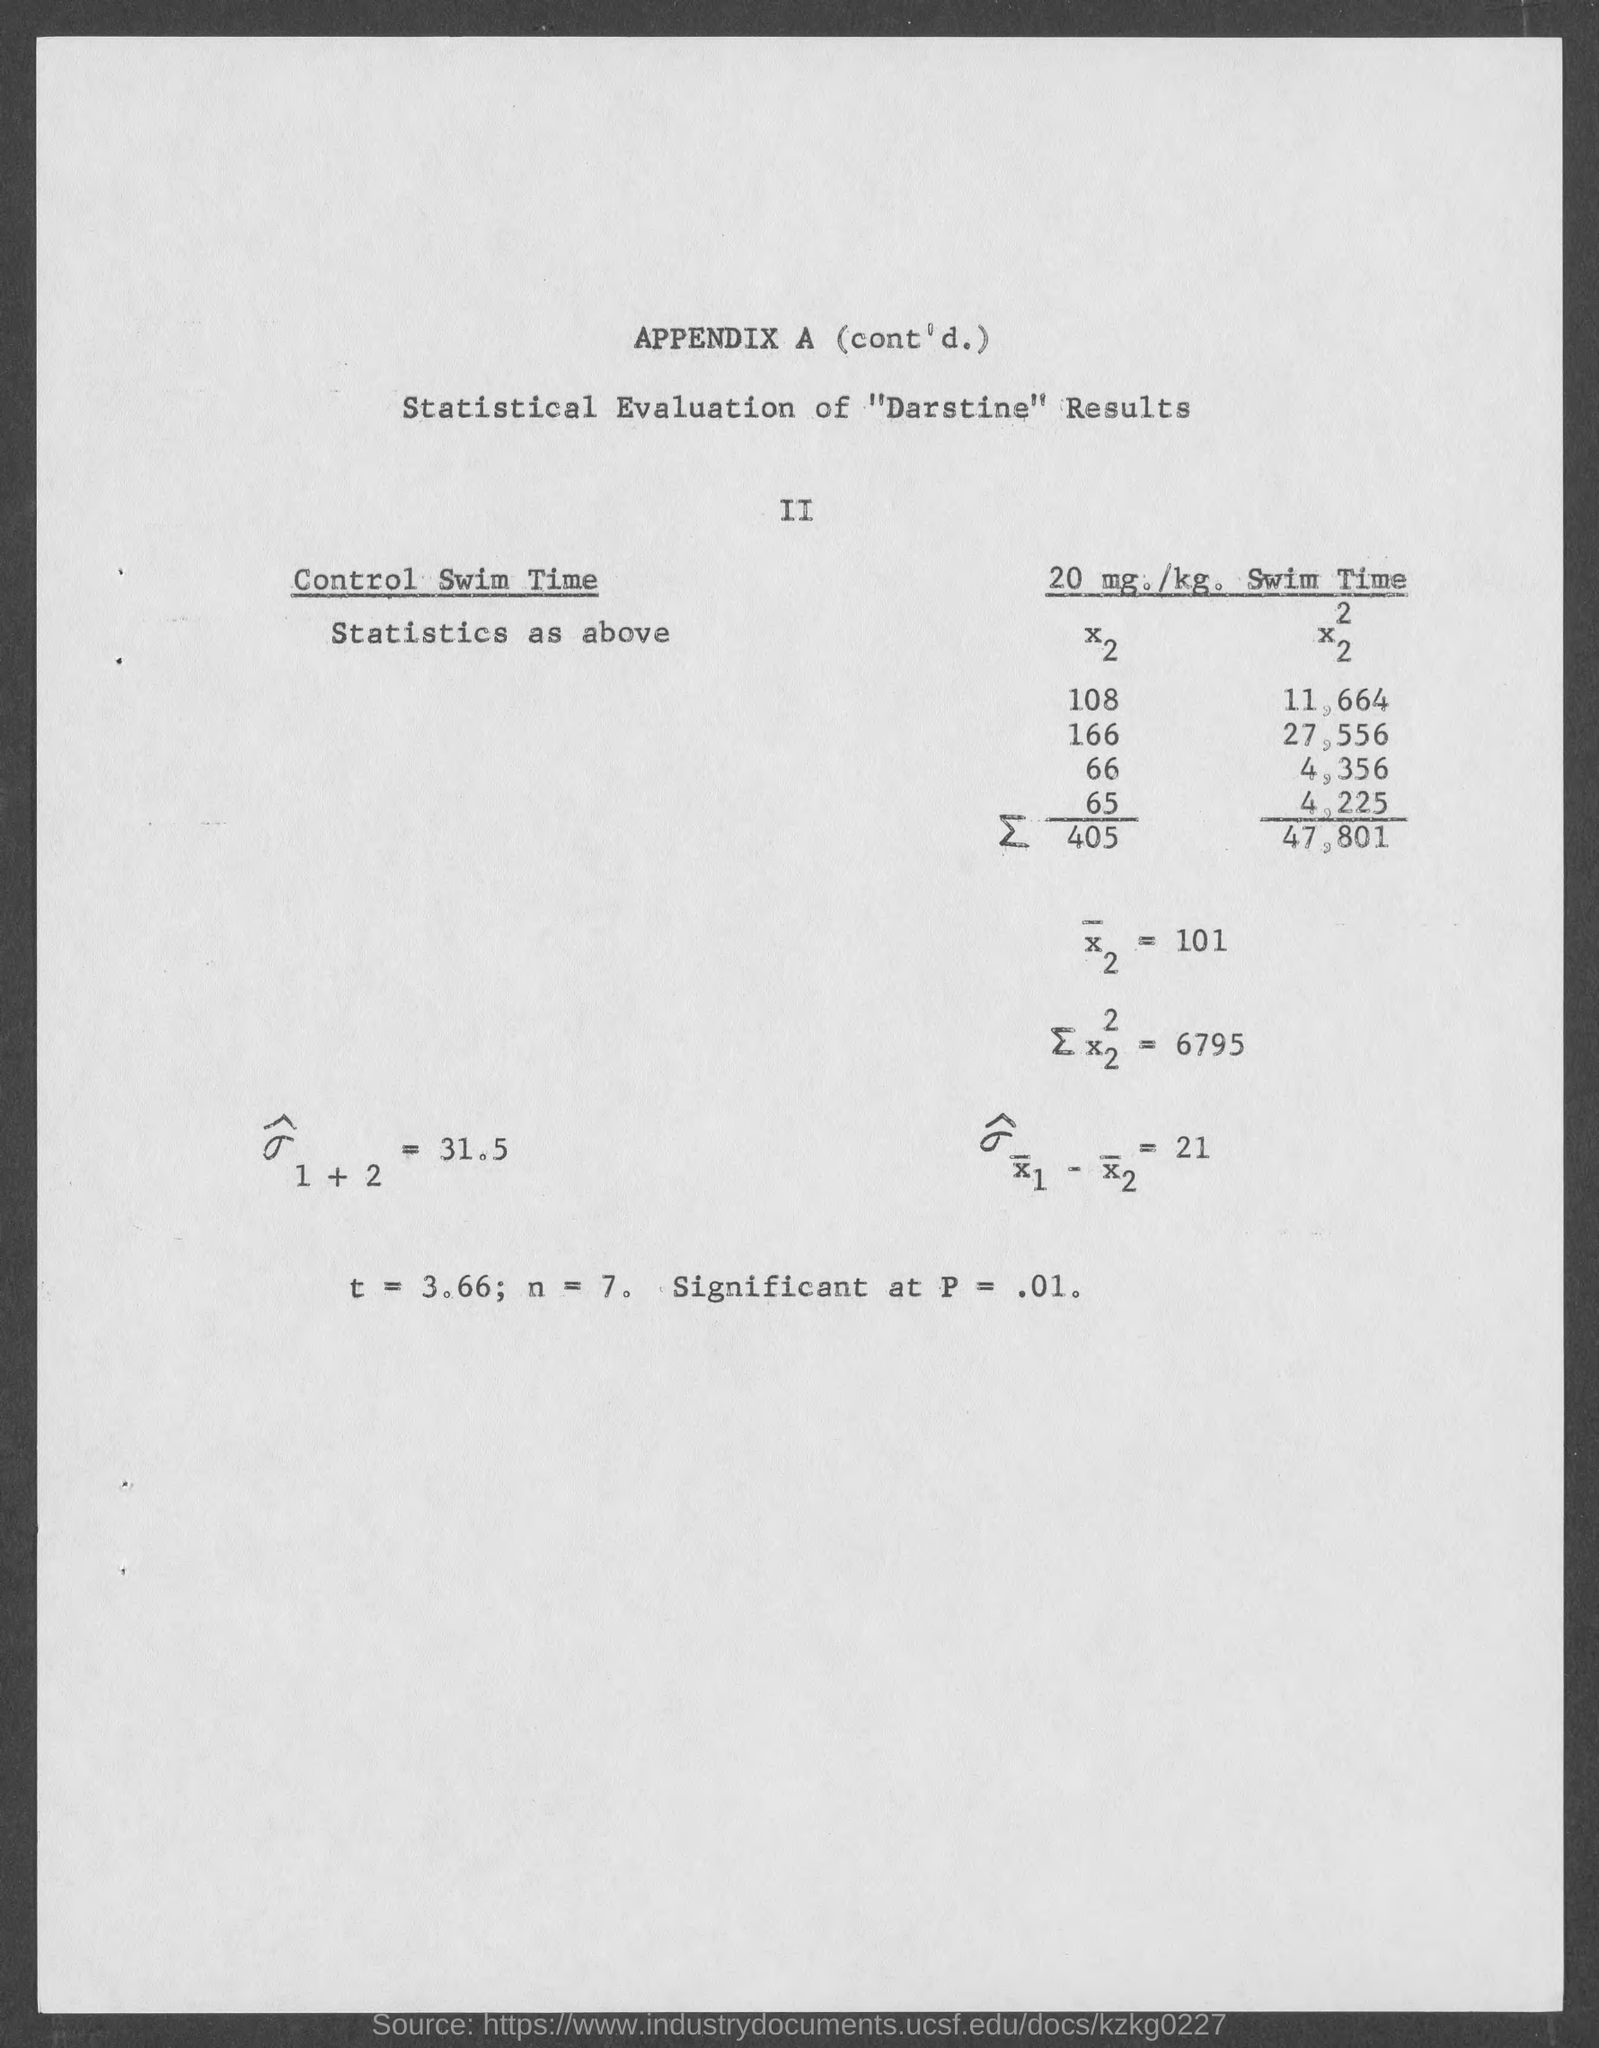Draw attention to some important aspects in this diagram. The value of n is equal to 7, with an optional leading decimal point. What is t equal to 3.66..." is a mathematical expression asking for the value of a specific variable, "t," when it is equal to 3.66. The results are considered significant at a p-value of .01, which means that there is strong evidence to support the conclusion that there is a significant difference between the two groups being compared. 